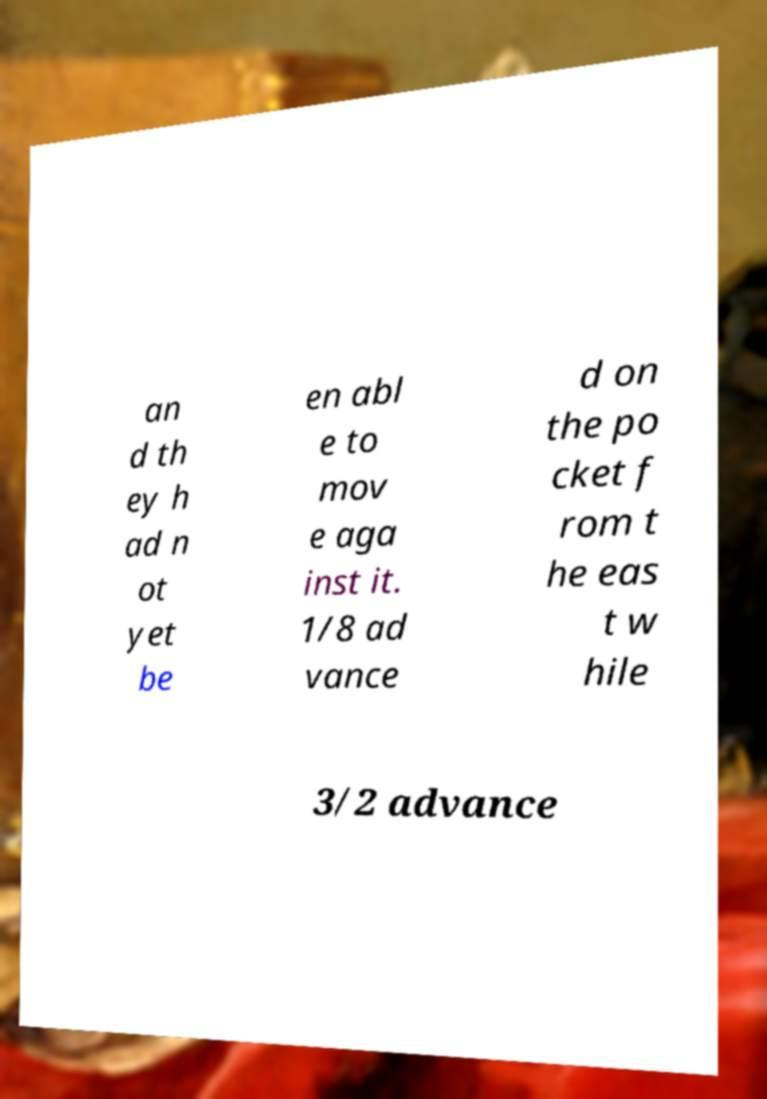I need the written content from this picture converted into text. Can you do that? an d th ey h ad n ot yet be en abl e to mov e aga inst it. 1/8 ad vance d on the po cket f rom t he eas t w hile 3/2 advance 